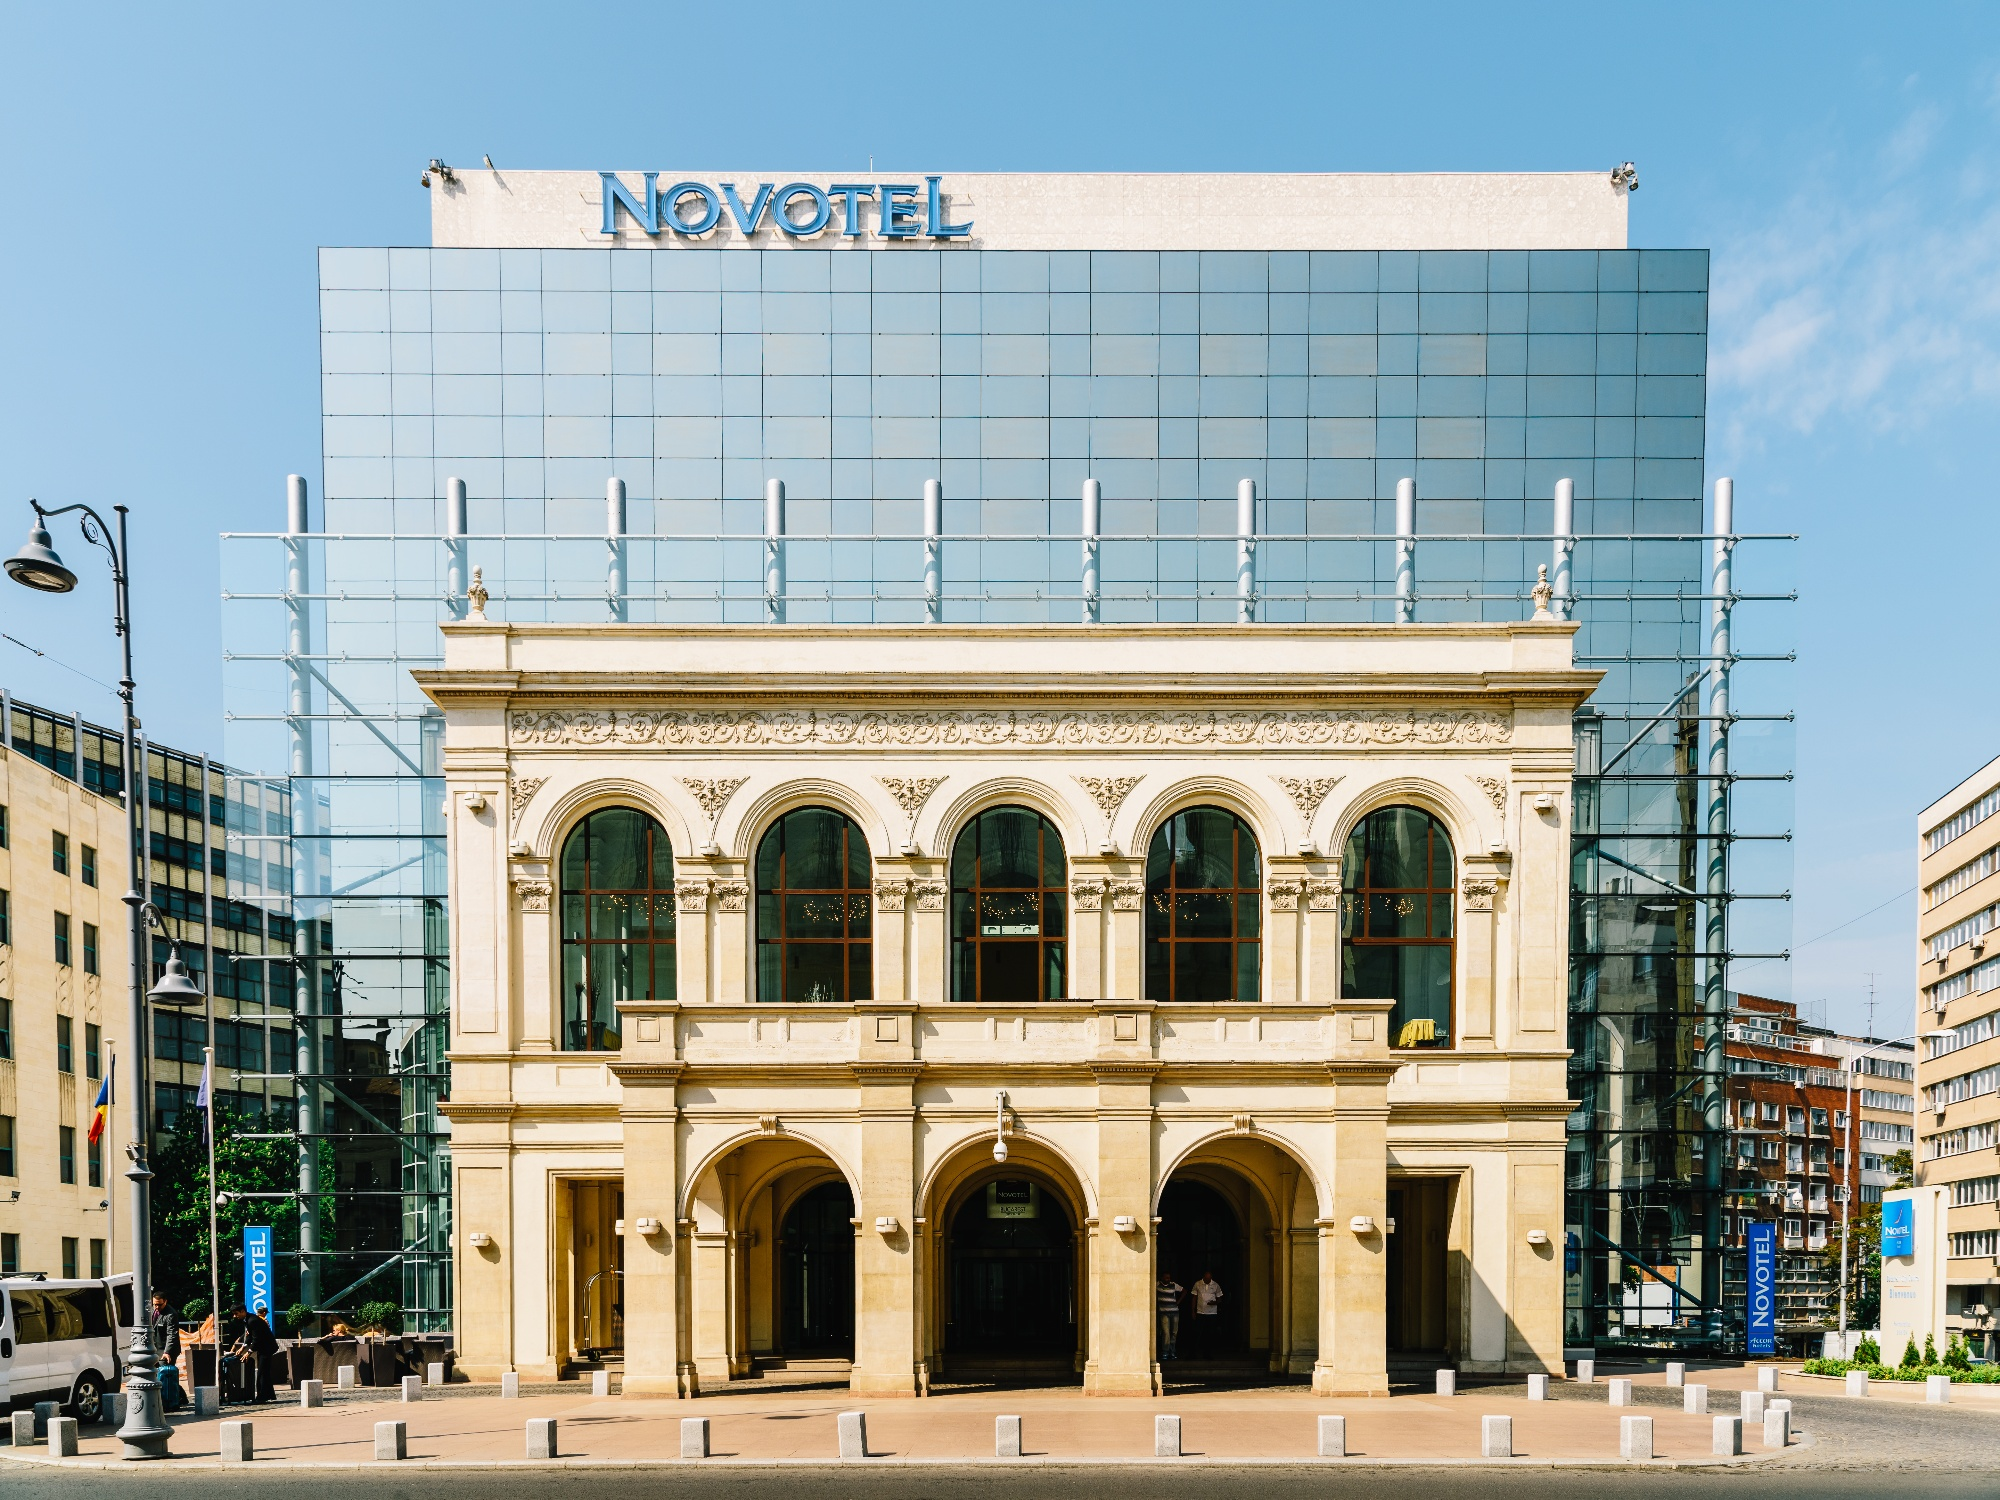What does the contrast in architectural styles between the upper and lower parts of the building signify? The contrasting architectural styles in the building's design highlight a blend of history and modernity. The ornate lower facade likely preserves the historical heritage of the site, possibly a renovated older building, while the modern glass upper introduces a contemporary aesthetic that aligns with current architectural trends. This combination often signifies an attempt to harmonize the past with the present, maintaining historical roots while providing modern amenities and designs. 